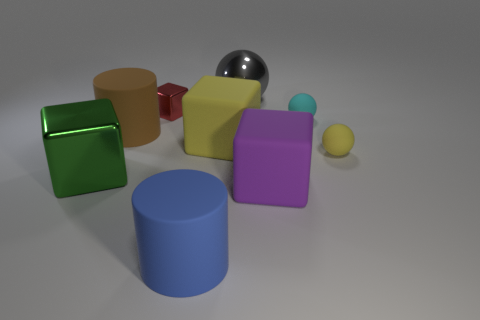Subtract all gray balls. How many balls are left? 2 Subtract all big purple cubes. How many cubes are left? 3 Subtract all purple balls. Subtract all gray cylinders. How many balls are left? 3 Add 1 large cyan shiny things. How many objects exist? 10 Subtract 0 green cylinders. How many objects are left? 9 Subtract all spheres. How many objects are left? 6 Subtract 2 spheres. How many spheres are left? 1 Subtract all green blocks. How many brown cylinders are left? 1 Subtract all spheres. Subtract all blue cylinders. How many objects are left? 5 Add 5 rubber cubes. How many rubber cubes are left? 7 